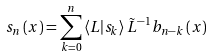Convert formula to latex. <formula><loc_0><loc_0><loc_500><loc_500>s _ { n } \left ( x \right ) = \sum _ { k = 0 } ^ { n } \left \langle L | s _ { k } \right \rangle \tilde { L } ^ { - 1 } b _ { n - k } \left ( x \right )</formula> 